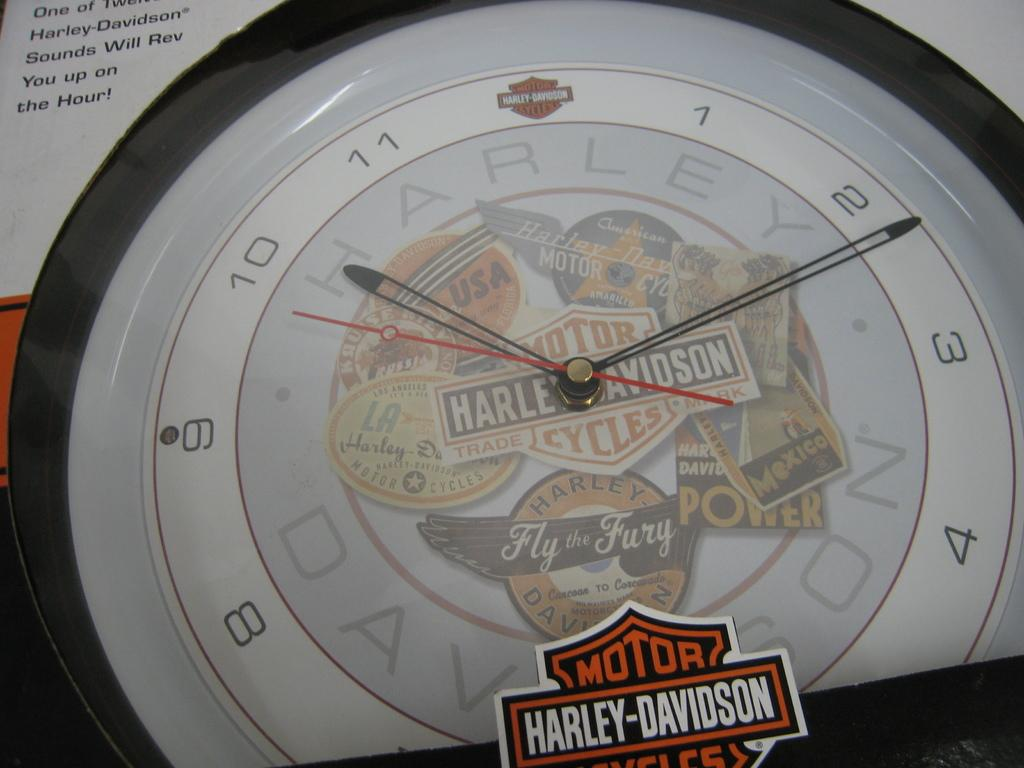<image>
Relay a brief, clear account of the picture shown. Harley Davidson Clock that says the current time is 10:12. 